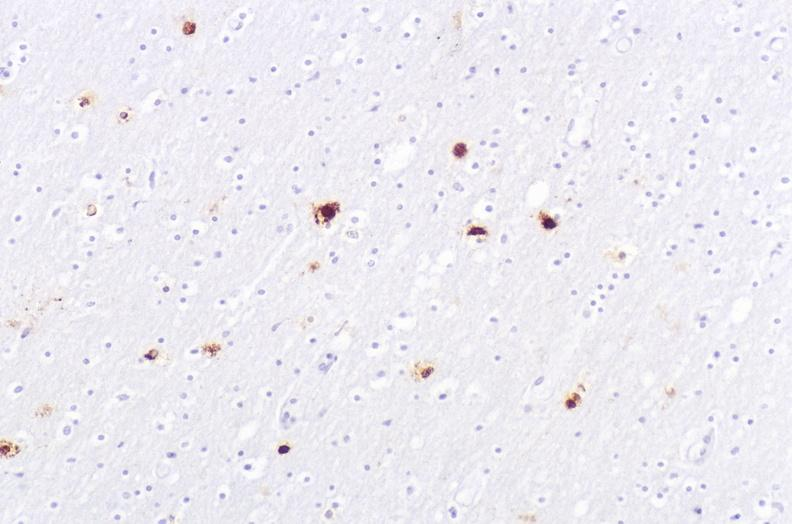s malignant thymoma present?
Answer the question using a single word or phrase. No 